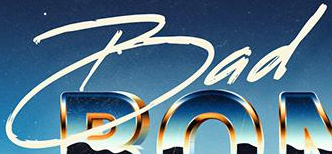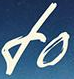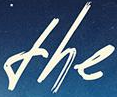What text appears in these images from left to right, separated by a semicolon? Bad; fo; the 